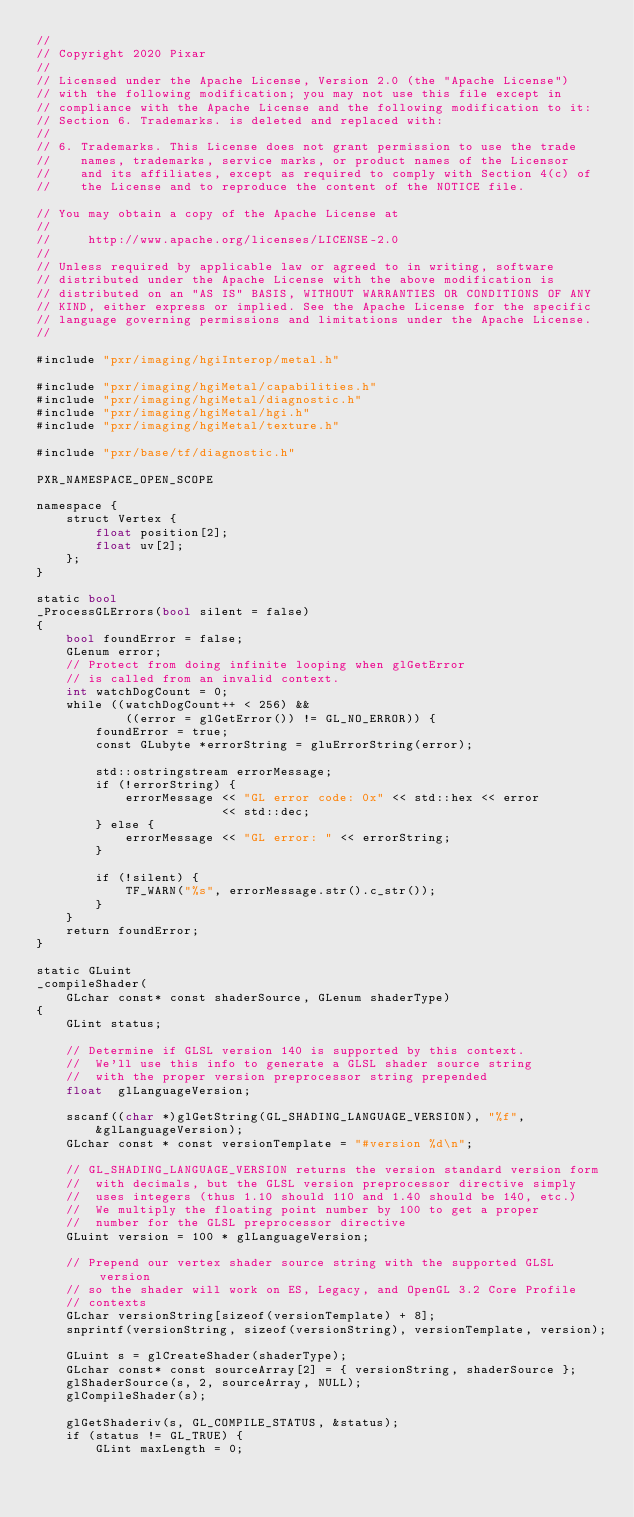<code> <loc_0><loc_0><loc_500><loc_500><_ObjectiveC_>//
// Copyright 2020 Pixar
//
// Licensed under the Apache License, Version 2.0 (the "Apache License")
// with the following modification; you may not use this file except in
// compliance with the Apache License and the following modification to it:
// Section 6. Trademarks. is deleted and replaced with:
//
// 6. Trademarks. This License does not grant permission to use the trade
//    names, trademarks, service marks, or product names of the Licensor
//    and its affiliates, except as required to comply with Section 4(c) of
//    the License and to reproduce the content of the NOTICE file.

// You may obtain a copy of the Apache License at
//
//     http://www.apache.org/licenses/LICENSE-2.0
//
// Unless required by applicable law or agreed to in writing, software
// distributed under the Apache License with the above modification is
// distributed on an "AS IS" BASIS, WITHOUT WARRANTIES OR CONDITIONS OF ANY
// KIND, either express or implied. See the Apache License for the specific
// language governing permissions and limitations under the Apache License.
//

#include "pxr/imaging/hgiInterop/metal.h"

#include "pxr/imaging/hgiMetal/capabilities.h"
#include "pxr/imaging/hgiMetal/diagnostic.h"
#include "pxr/imaging/hgiMetal/hgi.h"
#include "pxr/imaging/hgiMetal/texture.h"

#include "pxr/base/tf/diagnostic.h"

PXR_NAMESPACE_OPEN_SCOPE

namespace {
    struct Vertex {
        float position[2];
        float uv[2];
    };
}

static bool
_ProcessGLErrors(bool silent = false)
{
    bool foundError = false;
    GLenum error;
    // Protect from doing infinite looping when glGetError
    // is called from an invalid context.
    int watchDogCount = 0;
    while ((watchDogCount++ < 256) &&
            ((error = glGetError()) != GL_NO_ERROR)) {
        foundError = true;
        const GLubyte *errorString = gluErrorString(error);

        std::ostringstream errorMessage;
        if (!errorString) {
            errorMessage << "GL error code: 0x" << std::hex << error
                         << std::dec;
        } else {
            errorMessage << "GL error: " << errorString;
        }

        if (!silent) {
            TF_WARN("%s", errorMessage.str().c_str());
        }
    }
    return foundError;
}

static GLuint
_compileShader(
    GLchar const* const shaderSource, GLenum shaderType)
{
    GLint status;
    
    // Determine if GLSL version 140 is supported by this context.
    //  We'll use this info to generate a GLSL shader source string
    //  with the proper version preprocessor string prepended
    float  glLanguageVersion;
    
    sscanf((char *)glGetString(GL_SHADING_LANGUAGE_VERSION), "%f",
        &glLanguageVersion);
    GLchar const * const versionTemplate = "#version %d\n";
    
    // GL_SHADING_LANGUAGE_VERSION returns the version standard version form
    //  with decimals, but the GLSL version preprocessor directive simply
    //  uses integers (thus 1.10 should 110 and 1.40 should be 140, etc.)
    //  We multiply the floating point number by 100 to get a proper
    //  number for the GLSL preprocessor directive
    GLuint version = 100 * glLanguageVersion;
    
    // Prepend our vertex shader source string with the supported GLSL version
    // so the shader will work on ES, Legacy, and OpenGL 3.2 Core Profile
    // contexts
    GLchar versionString[sizeof(versionTemplate) + 8];
    snprintf(versionString, sizeof(versionString), versionTemplate, version);
    
    GLuint s = glCreateShader(shaderType);
    GLchar const* const sourceArray[2] = { versionString, shaderSource };
    glShaderSource(s, 2, sourceArray, NULL);
    glCompileShader(s);
    
    glGetShaderiv(s, GL_COMPILE_STATUS, &status);
    if (status != GL_TRUE) {
        GLint maxLength = 0;
        </code> 